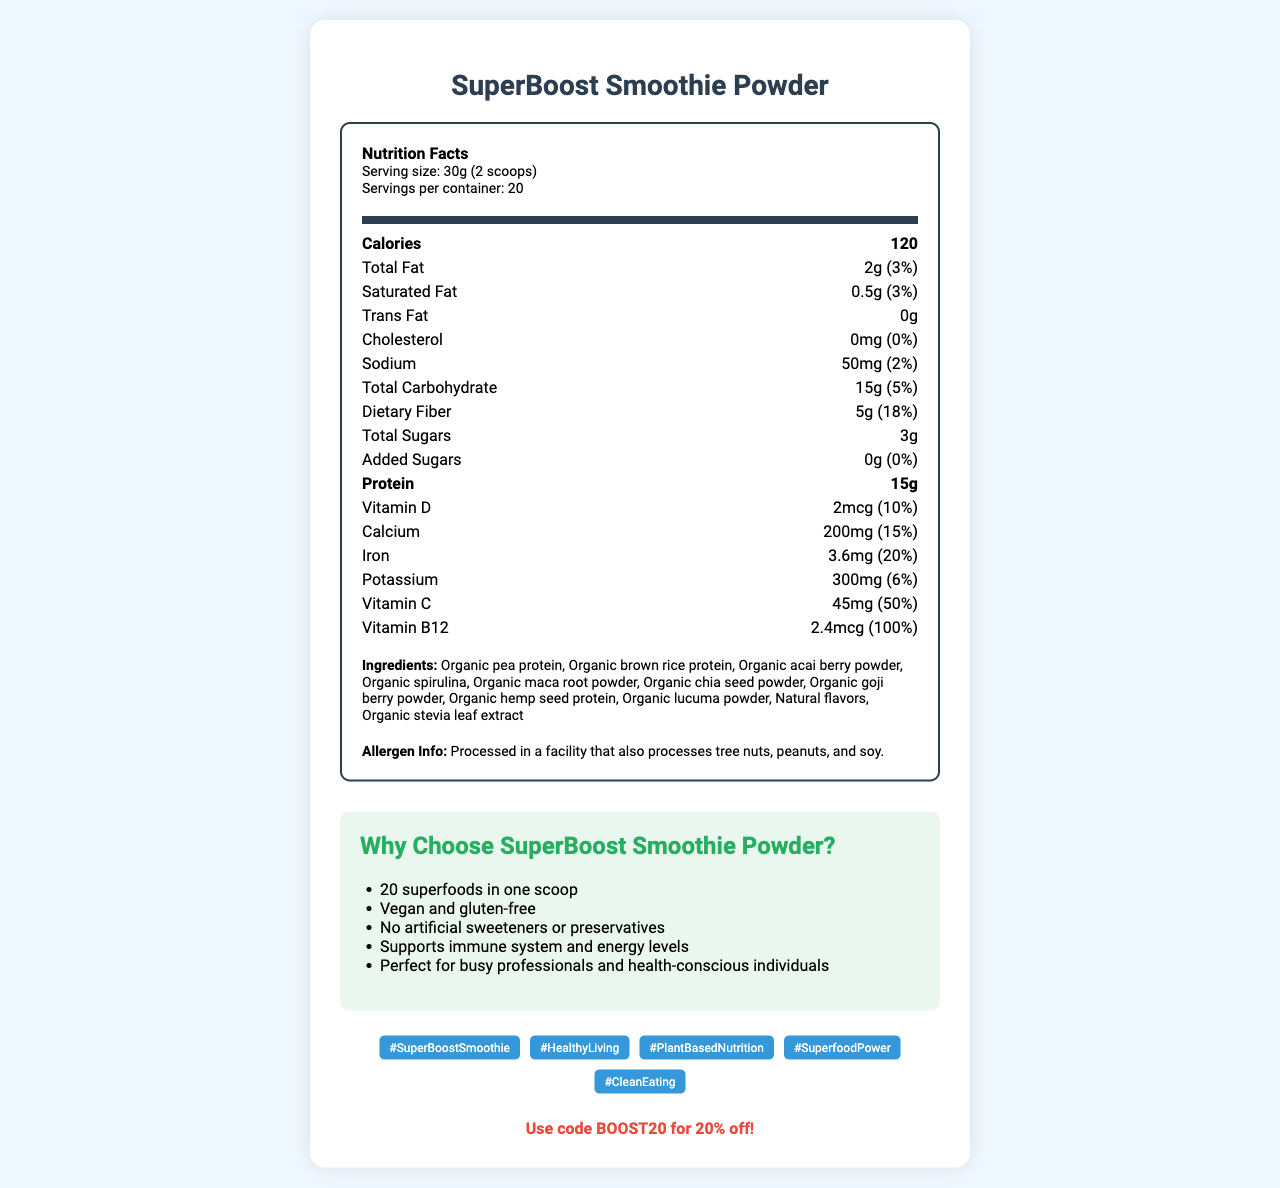what is the serving size? The serving size is listed under the Nutrition Facts header of the document.
Answer: 30g (2 scoops) how many servings are in one container? The document states that there are 20 servings per container.
Answer: 20 how many calories are in one serving? The calorie content per serving is prominently displayed under the Nutrition Facts.
Answer: 120 what is the total fat content per serving? The total fat content is specified as 2g in the nutrition label.
Answer: 2g how much dietary fiber is in one serving? The amount of dietary fiber per serving is 5g, as listed on the label.
Answer: 5g what is the allergen information? The allergen info is clearly stated near the bottom of the document under the ingredients section.
Answer: Processed in a facility that also processes tree nuts, peanuts, and soy. which of the following vitamins has the highest daily value in one serving? A. Vitamin D B. Calcium C. Iron D. Vitamin B12 The daily value for Vitamin B12 is 100%, which is the highest among the listed vitamins.
Answer: D which marketing claim is made about the product? A. Contains dairy B. No artificial sweeteners or preservatives C. Low sodium One of the marketing claims mentioned is "No artificial sweeteners or preservatives."
Answer: B is the product vegan and gluten-free? The document claims that "SuperBoost Smoothie Powder" is vegan and gluten-free.
Answer: Yes how many superfoods are claimed to be in one scoop? The marketing claims section mentions "20 superfoods in one scoop."
Answer: 20 superfoods what is the protein content per serving? The protein content per serving is shown as 15g.
Answer: 15g what is the main idea of this document? The document includes nutritional facts, ingredients, allergen information, marketing claims, social media hashtags, a digital coupon code, and a QR code link, all emphasizing the health benefits and promotional aspects of the product.
Answer: It provides detailed nutritional information about SuperBoost Smoothie Powder, highlighting its health benefits and marketing claims, and includes social media hashtags and a discount code. what is the QR code link? The link provided for the QR code is clearly stated in the document.
Answer: https://superboostsmoothie.com/nutrition who is the influencer partner? The influencer partnership is clearly mentioned as @FitFoodie_Sarah.
Answer: @FitFoodie_Sarah can you determine the price of the product from this document? The document does not provide any information regarding the price of the SuperBoost Smoothie Powder.
Answer: Not enough information 